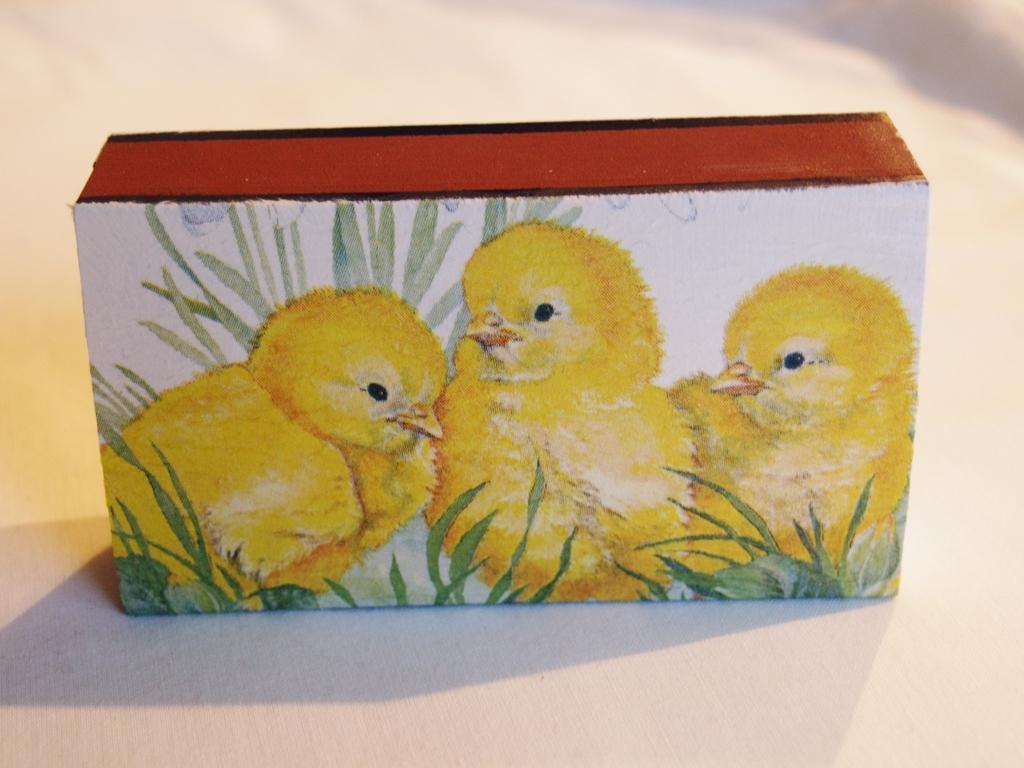What is depicted on the block in the image? There is a painting of chickens on the block. What is the color of the surface on which the block is placed? The block is placed on a white surface. How many apples are present in the image? There are no apples present in the image. What type of balls can be seen in the image? There are no balls present in the image. 